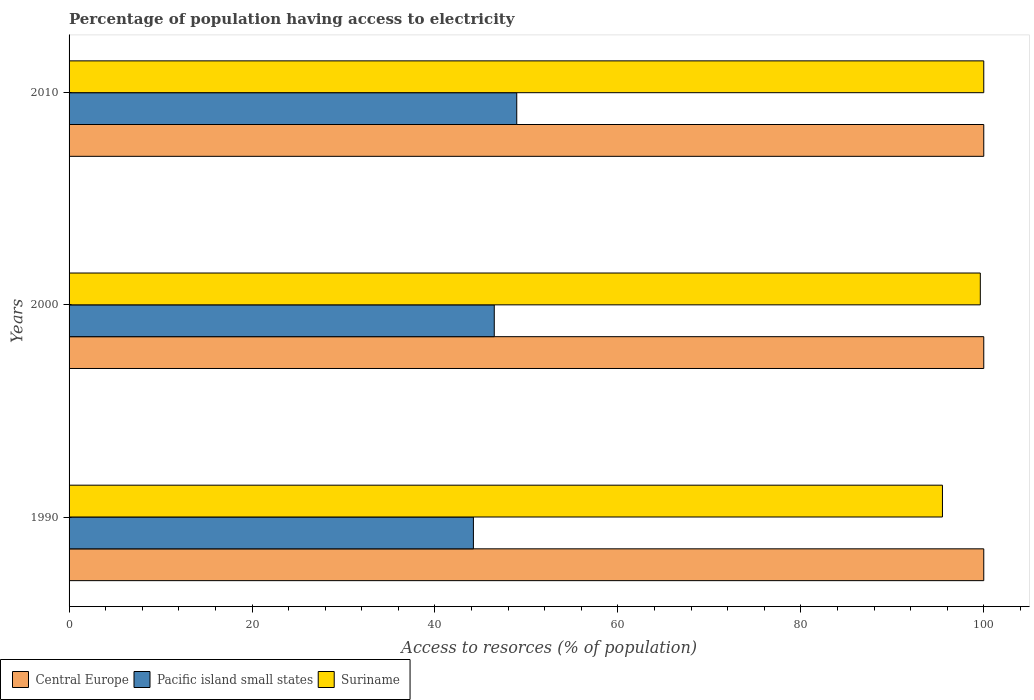How many groups of bars are there?
Ensure brevity in your answer.  3. Are the number of bars per tick equal to the number of legend labels?
Offer a terse response. Yes. How many bars are there on the 2nd tick from the top?
Your response must be concise. 3. In how many cases, is the number of bars for a given year not equal to the number of legend labels?
Offer a very short reply. 0. What is the percentage of population having access to electricity in Suriname in 2000?
Ensure brevity in your answer.  99.62. Across all years, what is the maximum percentage of population having access to electricity in Central Europe?
Offer a terse response. 100. Across all years, what is the minimum percentage of population having access to electricity in Suriname?
Offer a terse response. 95.49. What is the total percentage of population having access to electricity in Suriname in the graph?
Offer a very short reply. 295.11. What is the difference between the percentage of population having access to electricity in Suriname in 1990 and that in 2010?
Your answer should be very brief. -4.51. What is the difference between the percentage of population having access to electricity in Pacific island small states in 1990 and the percentage of population having access to electricity in Central Europe in 2000?
Your answer should be compact. -55.8. What is the average percentage of population having access to electricity in Suriname per year?
Ensure brevity in your answer.  98.37. In the year 2000, what is the difference between the percentage of population having access to electricity in Pacific island small states and percentage of population having access to electricity in Suriname?
Your answer should be compact. -53.14. What is the ratio of the percentage of population having access to electricity in Pacific island small states in 1990 to that in 2000?
Offer a very short reply. 0.95. Is the difference between the percentage of population having access to electricity in Pacific island small states in 2000 and 2010 greater than the difference between the percentage of population having access to electricity in Suriname in 2000 and 2010?
Your answer should be compact. No. What is the difference between the highest and the second highest percentage of population having access to electricity in Central Europe?
Give a very brief answer. 0. What is the difference between the highest and the lowest percentage of population having access to electricity in Pacific island small states?
Ensure brevity in your answer.  4.74. In how many years, is the percentage of population having access to electricity in Suriname greater than the average percentage of population having access to electricity in Suriname taken over all years?
Keep it short and to the point. 2. Is the sum of the percentage of population having access to electricity in Central Europe in 1990 and 2010 greater than the maximum percentage of population having access to electricity in Suriname across all years?
Provide a succinct answer. Yes. What does the 3rd bar from the top in 1990 represents?
Make the answer very short. Central Europe. What does the 2nd bar from the bottom in 2010 represents?
Give a very brief answer. Pacific island small states. Are the values on the major ticks of X-axis written in scientific E-notation?
Provide a succinct answer. No. Does the graph contain any zero values?
Offer a terse response. No. Does the graph contain grids?
Ensure brevity in your answer.  No. How many legend labels are there?
Provide a succinct answer. 3. How are the legend labels stacked?
Provide a short and direct response. Horizontal. What is the title of the graph?
Provide a short and direct response. Percentage of population having access to electricity. What is the label or title of the X-axis?
Give a very brief answer. Access to resorces (% of population). What is the Access to resorces (% of population) in Central Europe in 1990?
Ensure brevity in your answer.  100. What is the Access to resorces (% of population) of Pacific island small states in 1990?
Offer a terse response. 44.2. What is the Access to resorces (% of population) in Suriname in 1990?
Offer a very short reply. 95.49. What is the Access to resorces (% of population) in Central Europe in 2000?
Your answer should be very brief. 100. What is the Access to resorces (% of population) of Pacific island small states in 2000?
Your answer should be very brief. 46.48. What is the Access to resorces (% of population) of Suriname in 2000?
Your answer should be compact. 99.62. What is the Access to resorces (% of population) of Pacific island small states in 2010?
Offer a very short reply. 48.94. Across all years, what is the maximum Access to resorces (% of population) in Central Europe?
Ensure brevity in your answer.  100. Across all years, what is the maximum Access to resorces (% of population) in Pacific island small states?
Offer a very short reply. 48.94. Across all years, what is the minimum Access to resorces (% of population) of Pacific island small states?
Your answer should be compact. 44.2. Across all years, what is the minimum Access to resorces (% of population) of Suriname?
Give a very brief answer. 95.49. What is the total Access to resorces (% of population) in Central Europe in the graph?
Provide a succinct answer. 300. What is the total Access to resorces (% of population) in Pacific island small states in the graph?
Ensure brevity in your answer.  139.63. What is the total Access to resorces (% of population) in Suriname in the graph?
Ensure brevity in your answer.  295.11. What is the difference between the Access to resorces (% of population) of Pacific island small states in 1990 and that in 2000?
Provide a short and direct response. -2.28. What is the difference between the Access to resorces (% of population) in Suriname in 1990 and that in 2000?
Keep it short and to the point. -4.14. What is the difference between the Access to resorces (% of population) of Central Europe in 1990 and that in 2010?
Make the answer very short. 0. What is the difference between the Access to resorces (% of population) in Pacific island small states in 1990 and that in 2010?
Give a very brief answer. -4.74. What is the difference between the Access to resorces (% of population) of Suriname in 1990 and that in 2010?
Ensure brevity in your answer.  -4.51. What is the difference between the Access to resorces (% of population) in Central Europe in 2000 and that in 2010?
Your answer should be very brief. 0. What is the difference between the Access to resorces (% of population) in Pacific island small states in 2000 and that in 2010?
Provide a succinct answer. -2.46. What is the difference between the Access to resorces (% of population) in Suriname in 2000 and that in 2010?
Offer a very short reply. -0.38. What is the difference between the Access to resorces (% of population) of Central Europe in 1990 and the Access to resorces (% of population) of Pacific island small states in 2000?
Give a very brief answer. 53.52. What is the difference between the Access to resorces (% of population) of Central Europe in 1990 and the Access to resorces (% of population) of Suriname in 2000?
Provide a short and direct response. 0.38. What is the difference between the Access to resorces (% of population) of Pacific island small states in 1990 and the Access to resorces (% of population) of Suriname in 2000?
Give a very brief answer. -55.42. What is the difference between the Access to resorces (% of population) of Central Europe in 1990 and the Access to resorces (% of population) of Pacific island small states in 2010?
Provide a succinct answer. 51.06. What is the difference between the Access to resorces (% of population) in Central Europe in 1990 and the Access to resorces (% of population) in Suriname in 2010?
Offer a very short reply. 0. What is the difference between the Access to resorces (% of population) in Pacific island small states in 1990 and the Access to resorces (% of population) in Suriname in 2010?
Make the answer very short. -55.8. What is the difference between the Access to resorces (% of population) in Central Europe in 2000 and the Access to resorces (% of population) in Pacific island small states in 2010?
Your response must be concise. 51.06. What is the difference between the Access to resorces (% of population) of Pacific island small states in 2000 and the Access to resorces (% of population) of Suriname in 2010?
Offer a very short reply. -53.52. What is the average Access to resorces (% of population) of Pacific island small states per year?
Your answer should be very brief. 46.54. What is the average Access to resorces (% of population) of Suriname per year?
Ensure brevity in your answer.  98.37. In the year 1990, what is the difference between the Access to resorces (% of population) in Central Europe and Access to resorces (% of population) in Pacific island small states?
Give a very brief answer. 55.8. In the year 1990, what is the difference between the Access to resorces (% of population) of Central Europe and Access to resorces (% of population) of Suriname?
Provide a succinct answer. 4.51. In the year 1990, what is the difference between the Access to resorces (% of population) in Pacific island small states and Access to resorces (% of population) in Suriname?
Provide a short and direct response. -51.28. In the year 2000, what is the difference between the Access to resorces (% of population) of Central Europe and Access to resorces (% of population) of Pacific island small states?
Offer a very short reply. 53.52. In the year 2000, what is the difference between the Access to resorces (% of population) in Central Europe and Access to resorces (% of population) in Suriname?
Ensure brevity in your answer.  0.38. In the year 2000, what is the difference between the Access to resorces (% of population) in Pacific island small states and Access to resorces (% of population) in Suriname?
Provide a short and direct response. -53.14. In the year 2010, what is the difference between the Access to resorces (% of population) of Central Europe and Access to resorces (% of population) of Pacific island small states?
Give a very brief answer. 51.06. In the year 2010, what is the difference between the Access to resorces (% of population) in Central Europe and Access to resorces (% of population) in Suriname?
Ensure brevity in your answer.  0. In the year 2010, what is the difference between the Access to resorces (% of population) in Pacific island small states and Access to resorces (% of population) in Suriname?
Make the answer very short. -51.06. What is the ratio of the Access to resorces (% of population) of Central Europe in 1990 to that in 2000?
Make the answer very short. 1. What is the ratio of the Access to resorces (% of population) of Pacific island small states in 1990 to that in 2000?
Your answer should be very brief. 0.95. What is the ratio of the Access to resorces (% of population) in Suriname in 1990 to that in 2000?
Your answer should be very brief. 0.96. What is the ratio of the Access to resorces (% of population) of Pacific island small states in 1990 to that in 2010?
Provide a short and direct response. 0.9. What is the ratio of the Access to resorces (% of population) of Suriname in 1990 to that in 2010?
Provide a succinct answer. 0.95. What is the ratio of the Access to resorces (% of population) in Central Europe in 2000 to that in 2010?
Provide a short and direct response. 1. What is the ratio of the Access to resorces (% of population) of Pacific island small states in 2000 to that in 2010?
Offer a very short reply. 0.95. What is the ratio of the Access to resorces (% of population) of Suriname in 2000 to that in 2010?
Provide a succinct answer. 1. What is the difference between the highest and the second highest Access to resorces (% of population) of Central Europe?
Ensure brevity in your answer.  0. What is the difference between the highest and the second highest Access to resorces (% of population) of Pacific island small states?
Provide a short and direct response. 2.46. What is the difference between the highest and the second highest Access to resorces (% of population) of Suriname?
Make the answer very short. 0.38. What is the difference between the highest and the lowest Access to resorces (% of population) of Central Europe?
Make the answer very short. 0. What is the difference between the highest and the lowest Access to resorces (% of population) of Pacific island small states?
Ensure brevity in your answer.  4.74. What is the difference between the highest and the lowest Access to resorces (% of population) of Suriname?
Your answer should be compact. 4.51. 